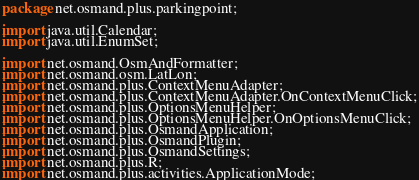Convert code to text. <code><loc_0><loc_0><loc_500><loc_500><_Java_>package net.osmand.plus.parkingpoint;

import java.util.Calendar;
import java.util.EnumSet;

import net.osmand.OsmAndFormatter;
import net.osmand.osm.LatLon;
import net.osmand.plus.ContextMenuAdapter;
import net.osmand.plus.ContextMenuAdapter.OnContextMenuClick;
import net.osmand.plus.OptionsMenuHelper;
import net.osmand.plus.OptionsMenuHelper.OnOptionsMenuClick;
import net.osmand.plus.OsmandApplication;
import net.osmand.plus.OsmandPlugin;
import net.osmand.plus.OsmandSettings;
import net.osmand.plus.R;
import net.osmand.plus.activities.ApplicationMode;</code> 